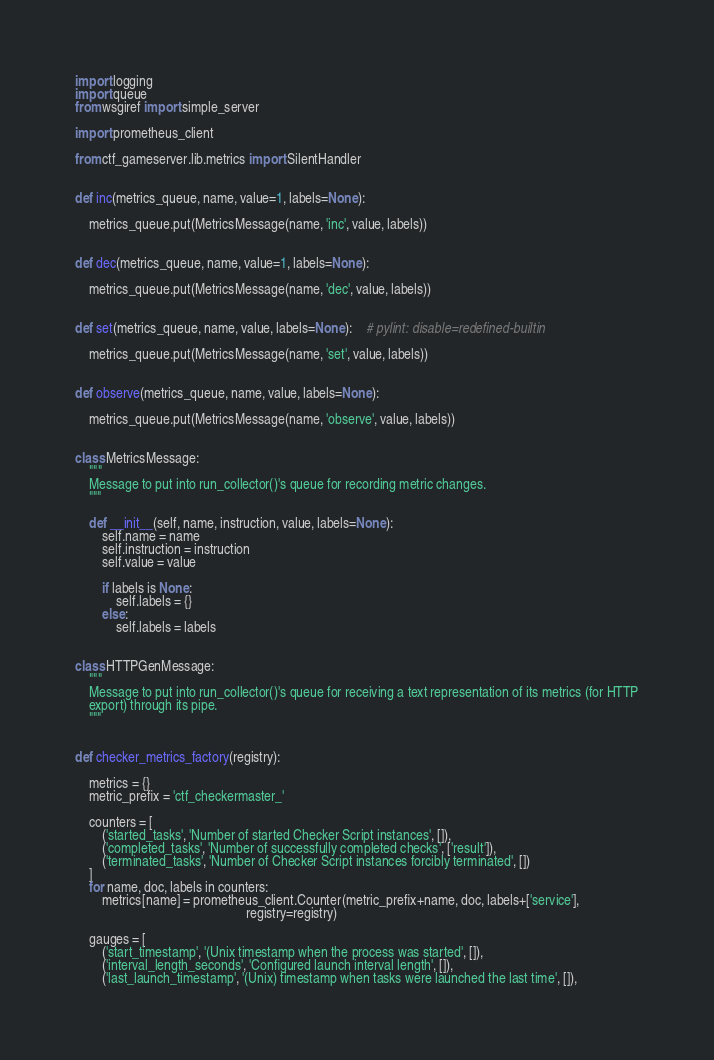<code> <loc_0><loc_0><loc_500><loc_500><_Python_>import logging
import queue
from wsgiref import simple_server

import prometheus_client

from ctf_gameserver.lib.metrics import SilentHandler


def inc(metrics_queue, name, value=1, labels=None):

    metrics_queue.put(MetricsMessage(name, 'inc', value, labels))


def dec(metrics_queue, name, value=1, labels=None):

    metrics_queue.put(MetricsMessage(name, 'dec', value, labels))


def set(metrics_queue, name, value, labels=None):    # pylint: disable=redefined-builtin

    metrics_queue.put(MetricsMessage(name, 'set', value, labels))


def observe(metrics_queue, name, value, labels=None):

    metrics_queue.put(MetricsMessage(name, 'observe', value, labels))


class MetricsMessage:
    """
    Message to put into run_collector()'s queue for recording metric changes.
    """

    def __init__(self, name, instruction, value, labels=None):
        self.name = name
        self.instruction = instruction
        self.value = value

        if labels is None:
            self.labels = {}
        else:
            self.labels = labels


class HTTPGenMessage:
    """
    Message to put into run_collector()'s queue for receiving a text representation of its metrics (for HTTP
    export) through its pipe.
    """


def checker_metrics_factory(registry):

    metrics = {}
    metric_prefix = 'ctf_checkermaster_'

    counters = [
        ('started_tasks', 'Number of started Checker Script instances', []),
        ('completed_tasks', 'Number of successfully completed checks', ['result']),
        ('terminated_tasks', 'Number of Checker Script instances forcibly terminated', [])
    ]
    for name, doc, labels in counters:
        metrics[name] = prometheus_client.Counter(metric_prefix+name, doc, labels+['service'],
                                                  registry=registry)

    gauges = [
        ('start_timestamp', '(Unix timestamp when the process was started', []),
        ('interval_length_seconds', 'Configured launch interval length', []),
        ('last_launch_timestamp', '(Unix) timestamp when tasks were launched the last time', []),</code> 